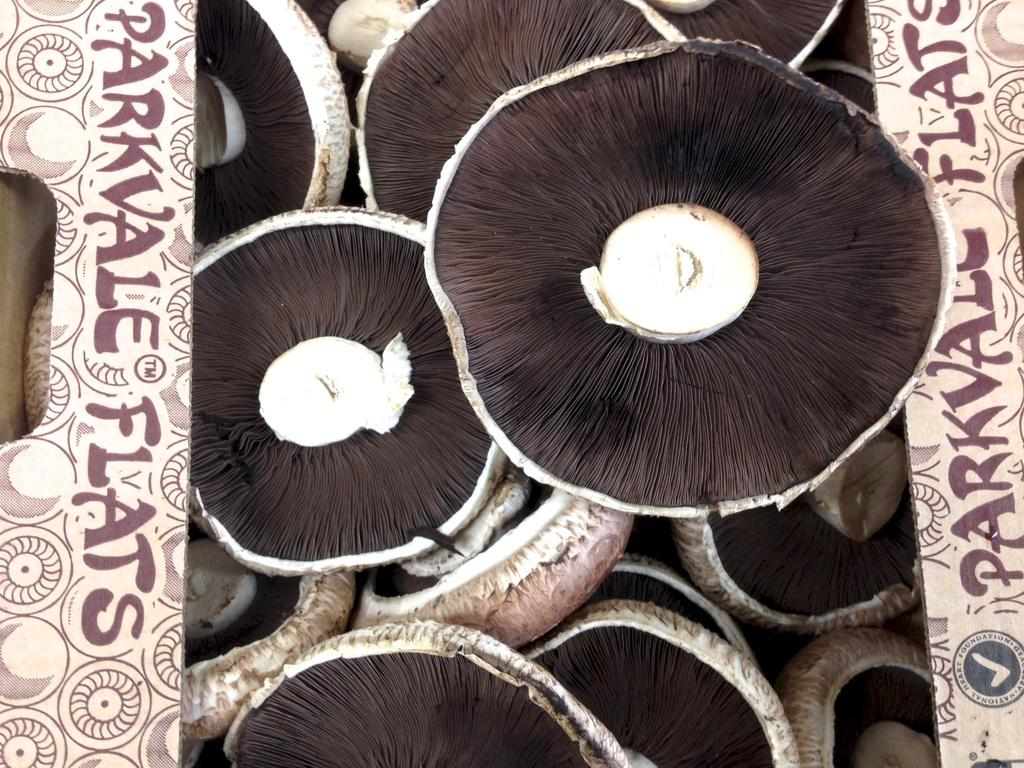What is inside the cardboard box in the image? There are mushrooms in the cardboard box. What else can be seen on the cardboard box? There is text on the cardboard box. How would you describe the color of the mushrooms? The mushrooms are in brown and cream color. What type of wind can be seen blowing through the image? There is no wind present in the image; it is a still image of mushrooms in a cardboard box. What date is marked on the calendar in the image? There is no calendar present in the image. 